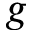Convert formula to latex. <formula><loc_0><loc_0><loc_500><loc_500>g</formula> 